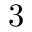Convert formula to latex. <formula><loc_0><loc_0><loc_500><loc_500>3</formula> 